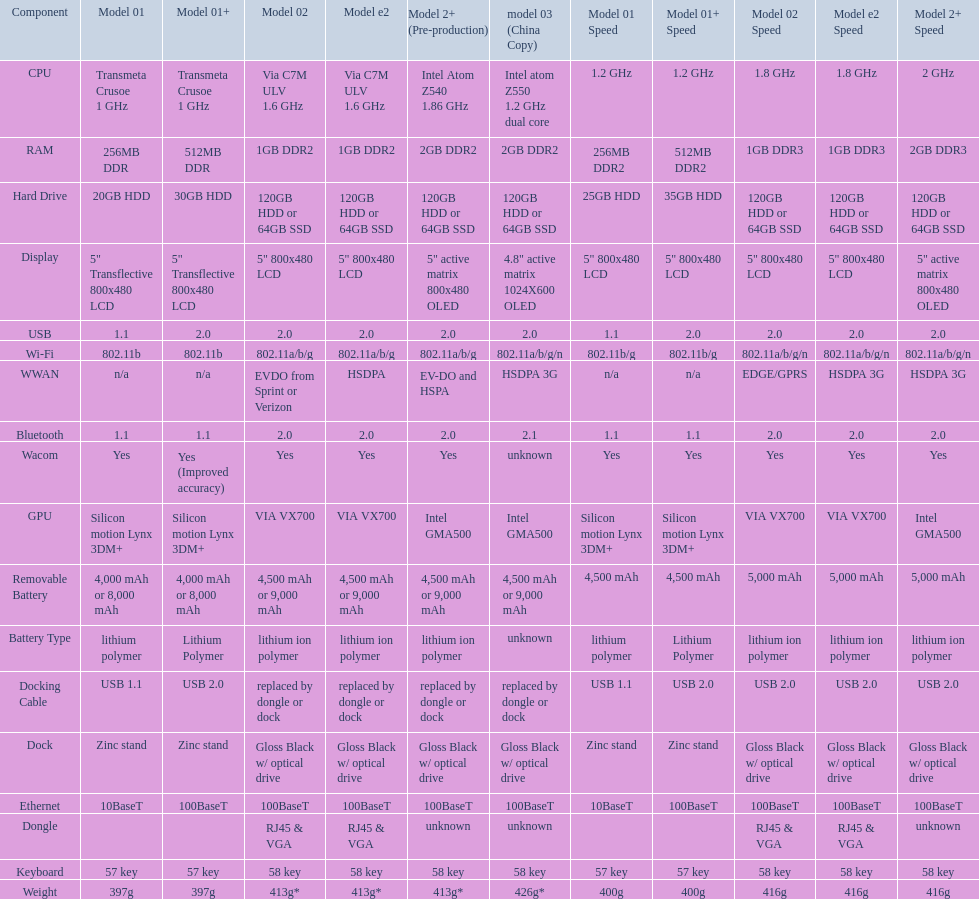How many models have 1.6ghz? 2. 